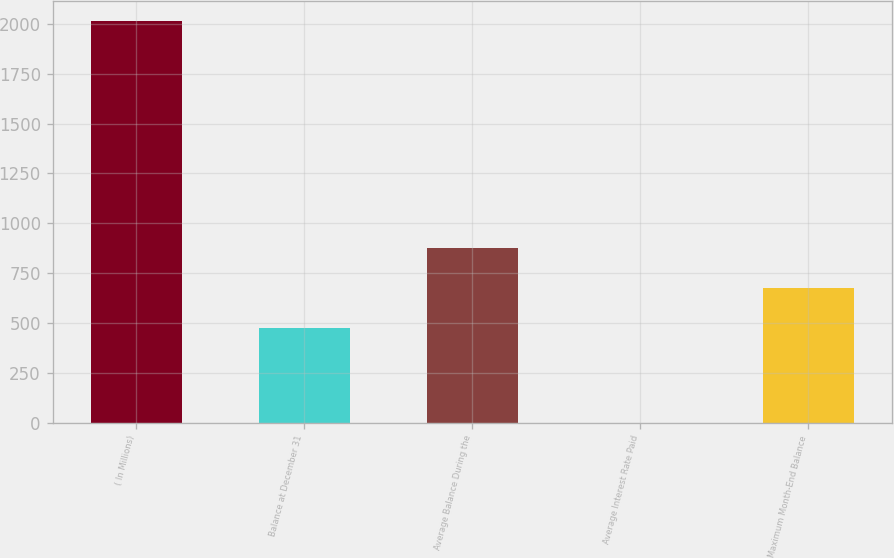Convert chart. <chart><loc_0><loc_0><loc_500><loc_500><bar_chart><fcel>( In Millions)<fcel>Balance at December 31<fcel>Average Balance During the<fcel>Average Interest Rate Paid<fcel>Maximum Month-End Balance<nl><fcel>2016<fcel>473.7<fcel>876.84<fcel>0.27<fcel>675.27<nl></chart> 